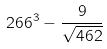<formula> <loc_0><loc_0><loc_500><loc_500>2 6 6 ^ { 3 } - \frac { 9 } { \sqrt { 4 6 2 } }</formula> 